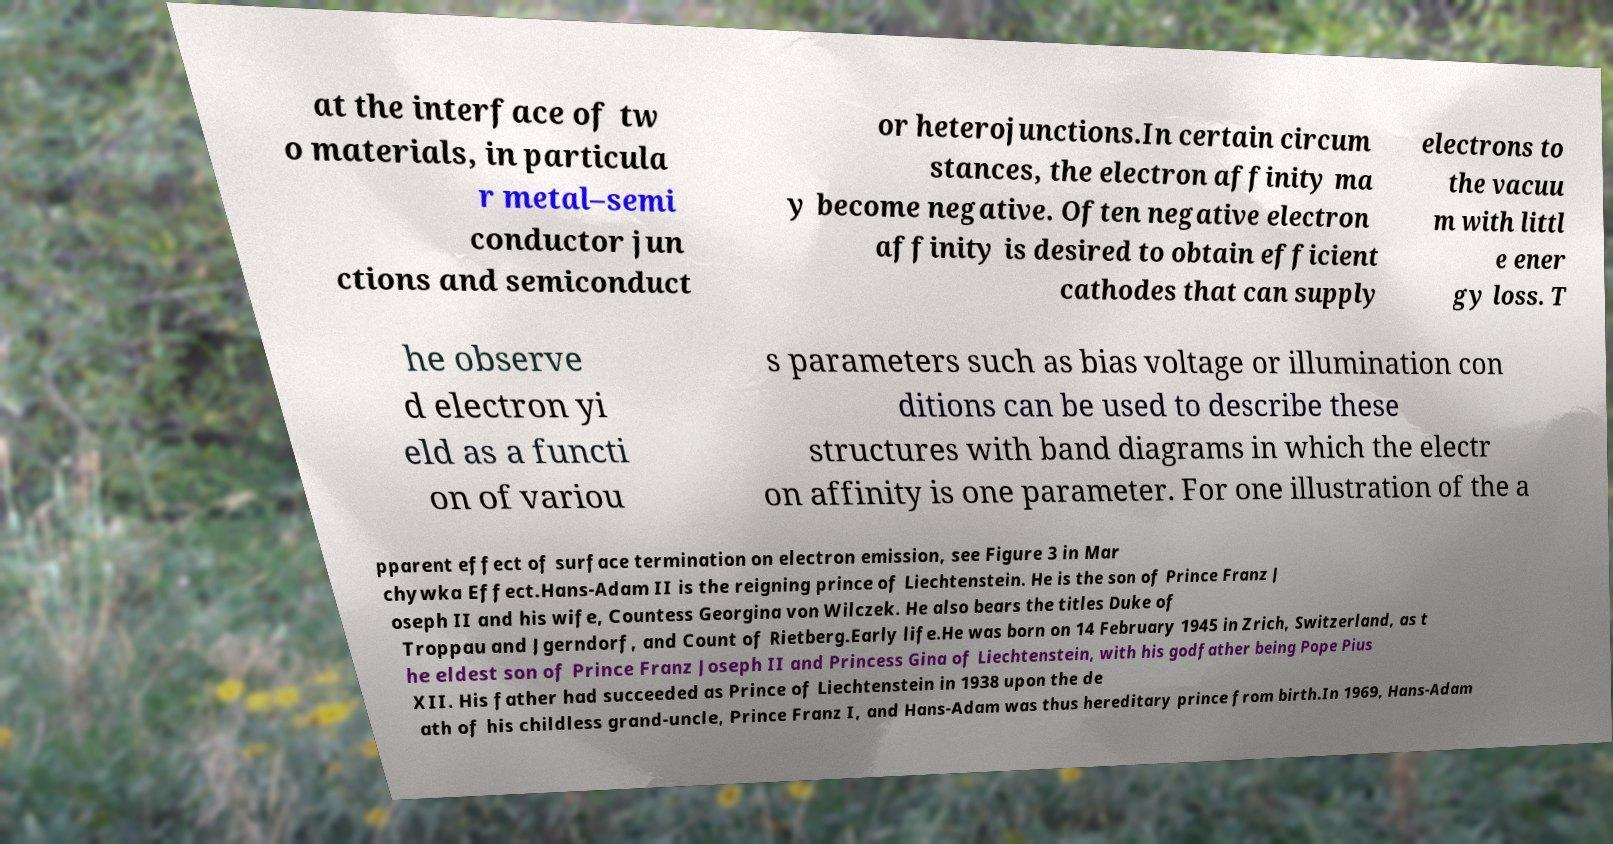Please identify and transcribe the text found in this image. at the interface of tw o materials, in particula r metal–semi conductor jun ctions and semiconduct or heterojunctions.In certain circum stances, the electron affinity ma y become negative. Often negative electron affinity is desired to obtain efficient cathodes that can supply electrons to the vacuu m with littl e ener gy loss. T he observe d electron yi eld as a functi on of variou s parameters such as bias voltage or illumination con ditions can be used to describe these structures with band diagrams in which the electr on affinity is one parameter. For one illustration of the a pparent effect of surface termination on electron emission, see Figure 3 in Mar chywka Effect.Hans-Adam II is the reigning prince of Liechtenstein. He is the son of Prince Franz J oseph II and his wife, Countess Georgina von Wilczek. He also bears the titles Duke of Troppau and Jgerndorf, and Count of Rietberg.Early life.He was born on 14 February 1945 in Zrich, Switzerland, as t he eldest son of Prince Franz Joseph II and Princess Gina of Liechtenstein, with his godfather being Pope Pius XII. His father had succeeded as Prince of Liechtenstein in 1938 upon the de ath of his childless grand-uncle, Prince Franz I, and Hans-Adam was thus hereditary prince from birth.In 1969, Hans-Adam 